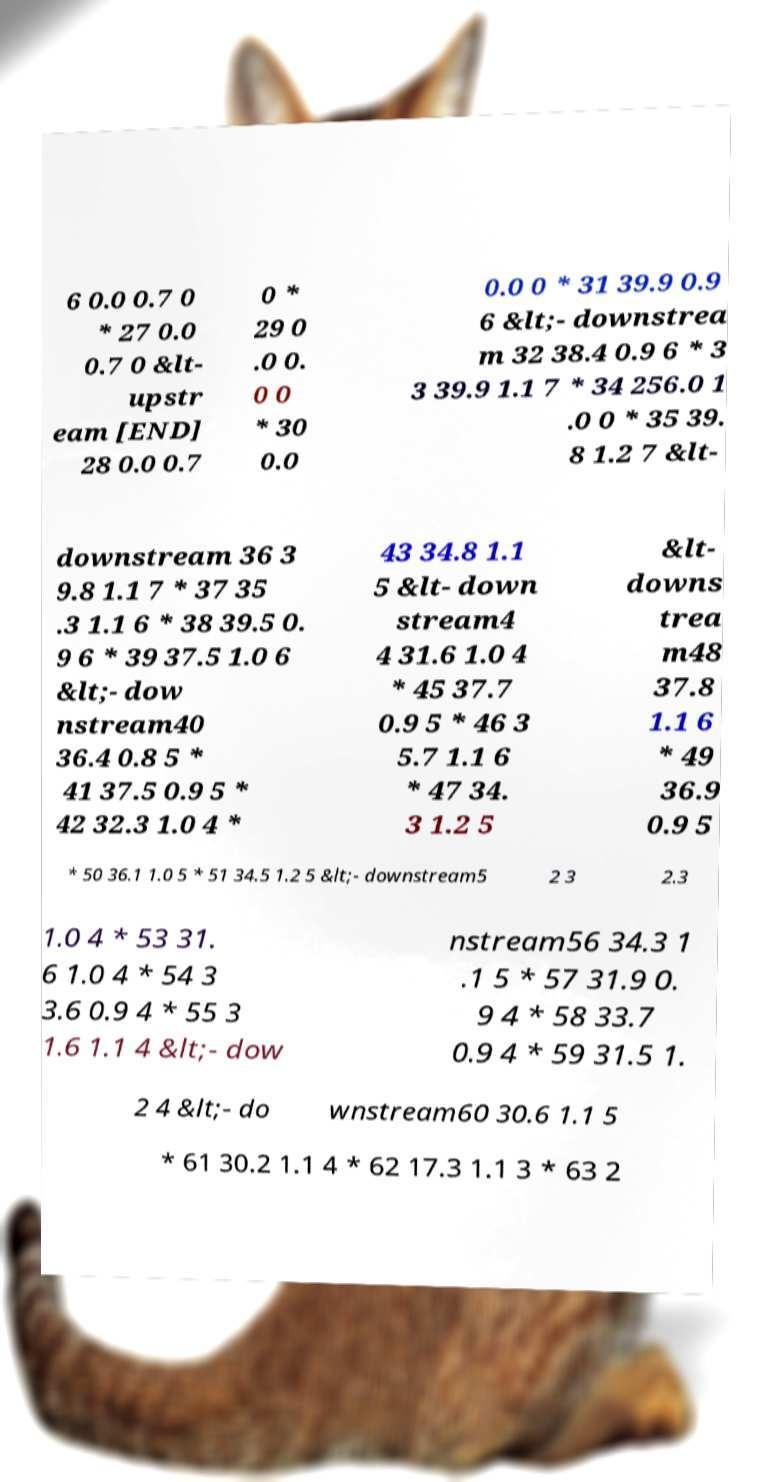For documentation purposes, I need the text within this image transcribed. Could you provide that? 6 0.0 0.7 0 * 27 0.0 0.7 0 &lt- upstr eam   28 0.0 0.7 0 * 29 0 .0 0. 0 0 * 30 0.0 0.0 0 * 31 39.9 0.9 6 &lt;- downstrea m 32 38.4 0.9 6 * 3 3 39.9 1.1 7 * 34 256.0 1 .0 0 * 35 39. 8 1.2 7 &lt- downstream 36 3 9.8 1.1 7 * 37 35 .3 1.1 6 * 38 39.5 0. 9 6 * 39 37.5 1.0 6 &lt;- dow nstream40 36.4 0.8 5 * 41 37.5 0.9 5 * 42 32.3 1.0 4 * 43 34.8 1.1 5 &lt- down stream4 4 31.6 1.0 4 * 45 37.7 0.9 5 * 46 3 5.7 1.1 6 * 47 34. 3 1.2 5 &lt- downs trea m48 37.8 1.1 6 * 49 36.9 0.9 5 * 50 36.1 1.0 5 * 51 34.5 1.2 5 &lt;- downstream5 2 3 2.3 1.0 4 * 53 31. 6 1.0 4 * 54 3 3.6 0.9 4 * 55 3 1.6 1.1 4 &lt;- dow nstream56 34.3 1 .1 5 * 57 31.9 0. 9 4 * 58 33.7 0.9 4 * 59 31.5 1. 2 4 &lt;- do wnstream60 30.6 1.1 5 * 61 30.2 1.1 4 * 62 17.3 1.1 3 * 63 2 